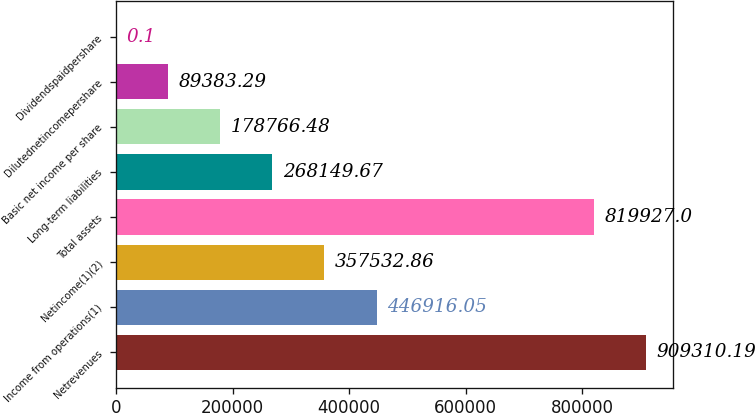Convert chart. <chart><loc_0><loc_0><loc_500><loc_500><bar_chart><fcel>Netrevenues<fcel>Income from operations(1)<fcel>Netincome(1)(2)<fcel>Total assets<fcel>Long-term liabilities<fcel>Basic net income per share<fcel>Dilutednetincomepershare<fcel>Dividendspaidpershare<nl><fcel>909310<fcel>446916<fcel>357533<fcel>819927<fcel>268150<fcel>178766<fcel>89383.3<fcel>0.1<nl></chart> 